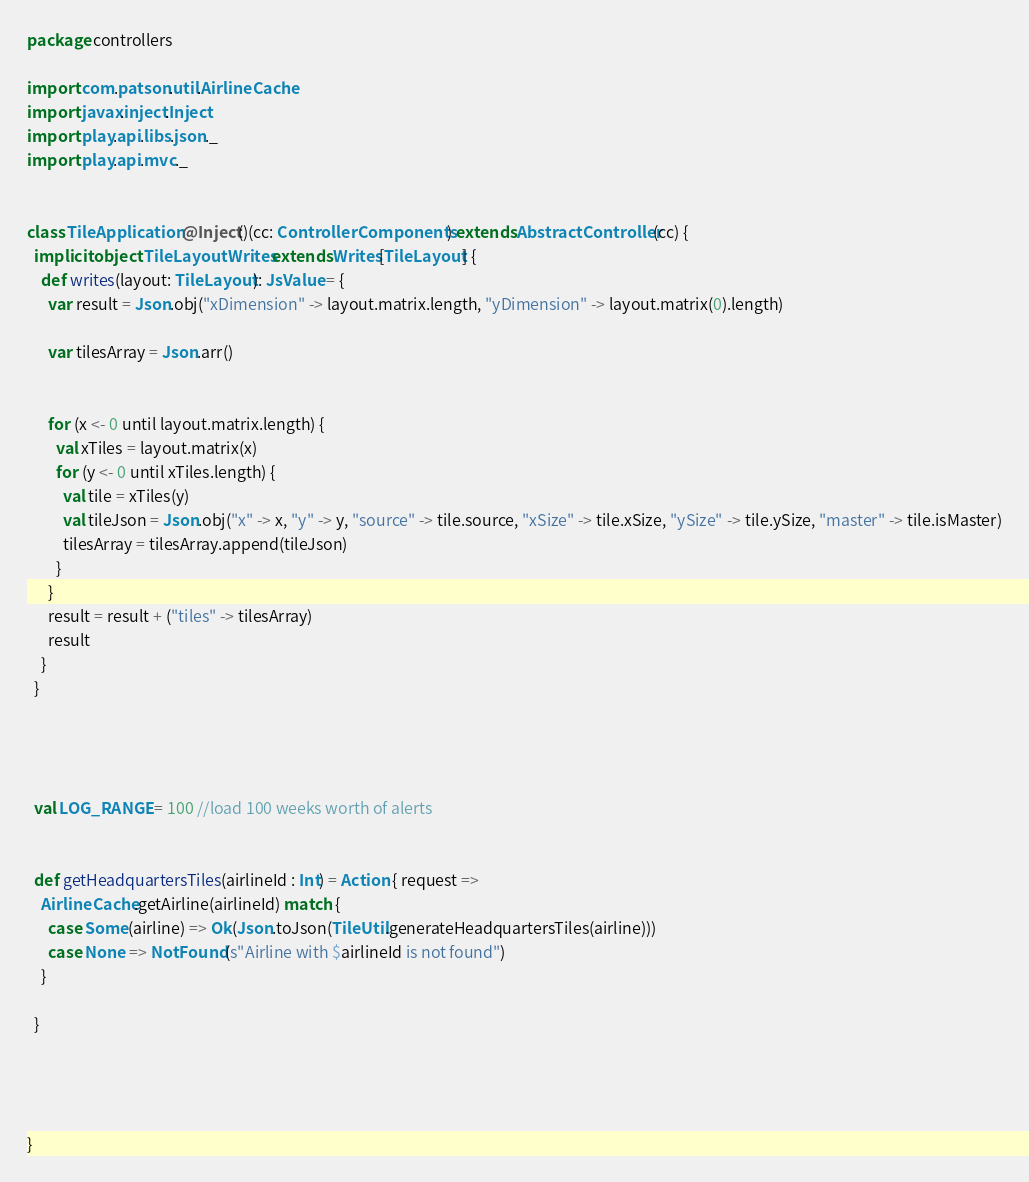Convert code to text. <code><loc_0><loc_0><loc_500><loc_500><_Scala_>package controllers

import com.patson.util.AirlineCache
import javax.inject.Inject
import play.api.libs.json._
import play.api.mvc._


class TileApplication @Inject()(cc: ControllerComponents) extends AbstractController(cc) {
  implicit object TileLayoutWrites extends Writes[TileLayout] {
    def writes(layout: TileLayout): JsValue = {
      var result = Json.obj("xDimension" -> layout.matrix.length, "yDimension" -> layout.matrix(0).length)

      var tilesArray = Json.arr()


      for (x <- 0 until layout.matrix.length) {
        val xTiles = layout.matrix(x)
        for (y <- 0 until xTiles.length) {
          val tile = xTiles(y)
          val tileJson = Json.obj("x" -> x, "y" -> y, "source" -> tile.source, "xSize" -> tile.xSize, "ySize" -> tile.ySize, "master" -> tile.isMaster)
          tilesArray = tilesArray.append(tileJson)
        }
      }
      result = result + ("tiles" -> tilesArray)
      result
    }
  }


  
  
  val LOG_RANGE = 100 //load 100 weeks worth of alerts
  
  
  def getHeadquartersTiles(airlineId : Int) = Action { request =>
    AirlineCache.getAirline(airlineId) match {
      case Some(airline) => Ok(Json.toJson(TileUtil.generateHeadquartersTiles(airline)))
      case None => NotFound(s"Airline with $airlineId is not found")
    }

  }
  
  

  
}
</code> 